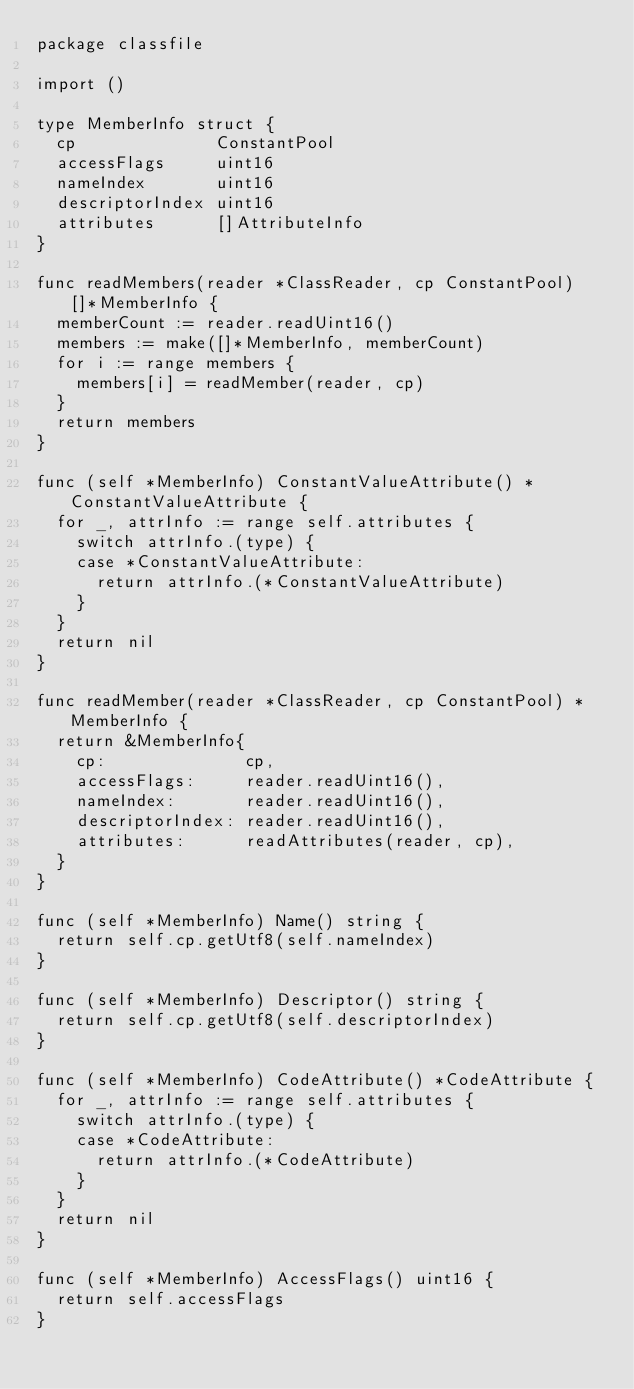Convert code to text. <code><loc_0><loc_0><loc_500><loc_500><_Go_>package classfile

import ()

type MemberInfo struct {
	cp              ConstantPool
	accessFlags     uint16
	nameIndex       uint16
	descriptorIndex uint16
	attributes      []AttributeInfo
}

func readMembers(reader *ClassReader, cp ConstantPool) []*MemberInfo {
	memberCount := reader.readUint16()
	members := make([]*MemberInfo, memberCount)
	for i := range members {
		members[i] = readMember(reader, cp)
	}
	return members
}

func (self *MemberInfo) ConstantValueAttribute() *ConstantValueAttribute {
	for _, attrInfo := range self.attributes {
		switch attrInfo.(type) {
		case *ConstantValueAttribute:
			return attrInfo.(*ConstantValueAttribute)
		}
	}
	return nil
}

func readMember(reader *ClassReader, cp ConstantPool) *MemberInfo {
	return &MemberInfo{
		cp:              cp,
		accessFlags:     reader.readUint16(),
		nameIndex:       reader.readUint16(),
		descriptorIndex: reader.readUint16(),
		attributes:      readAttributes(reader, cp),
	}
}

func (self *MemberInfo) Name() string {
	return self.cp.getUtf8(self.nameIndex)
}

func (self *MemberInfo) Descriptor() string {
	return self.cp.getUtf8(self.descriptorIndex)
}

func (self *MemberInfo) CodeAttribute() *CodeAttribute {
	for _, attrInfo := range self.attributes {
		switch attrInfo.(type) {
		case *CodeAttribute:
			return attrInfo.(*CodeAttribute)
		}
	}
	return nil
}

func (self *MemberInfo) AccessFlags() uint16 {
	return self.accessFlags
}
</code> 